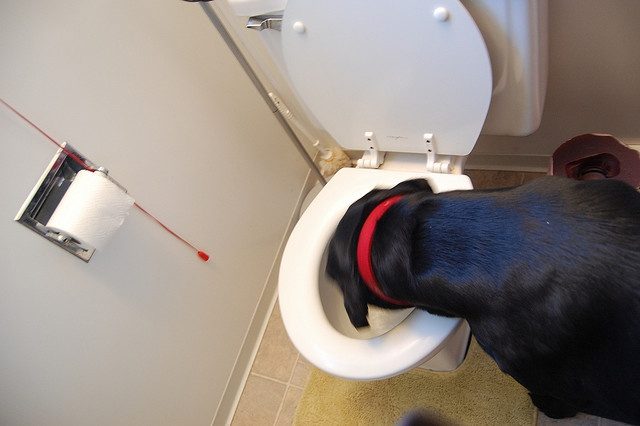Describe the objects in this image and their specific colors. I can see dog in darkgray, black, navy, and darkblue tones and toilet in darkgray and lightgray tones in this image. 